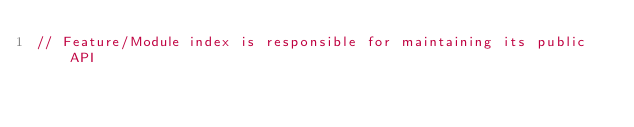Convert code to text. <code><loc_0><loc_0><loc_500><loc_500><_JavaScript_>// Feature/Module index is responsible for maintaining its public API</code> 